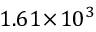Convert formula to latex. <formula><loc_0><loc_0><loc_500><loc_500>1 . 6 1 \, \times \, 1 0 ^ { 3 }</formula> 